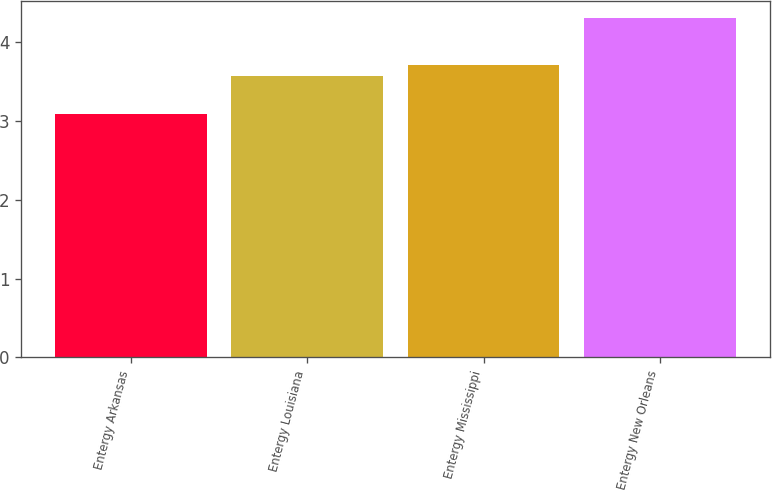<chart> <loc_0><loc_0><loc_500><loc_500><bar_chart><fcel>Entergy Arkansas<fcel>Entergy Louisiana<fcel>Entergy Mississippi<fcel>Entergy New Orleans<nl><fcel>3.09<fcel>3.57<fcel>3.71<fcel>4.3<nl></chart> 